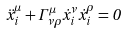Convert formula to latex. <formula><loc_0><loc_0><loc_500><loc_500>\ddot { x } _ { i } ^ { \mu } + \Gamma ^ { \mu } _ { \nu \rho } \dot { x } _ { i } ^ { \nu } \dot { x } _ { i } ^ { \rho } = 0</formula> 